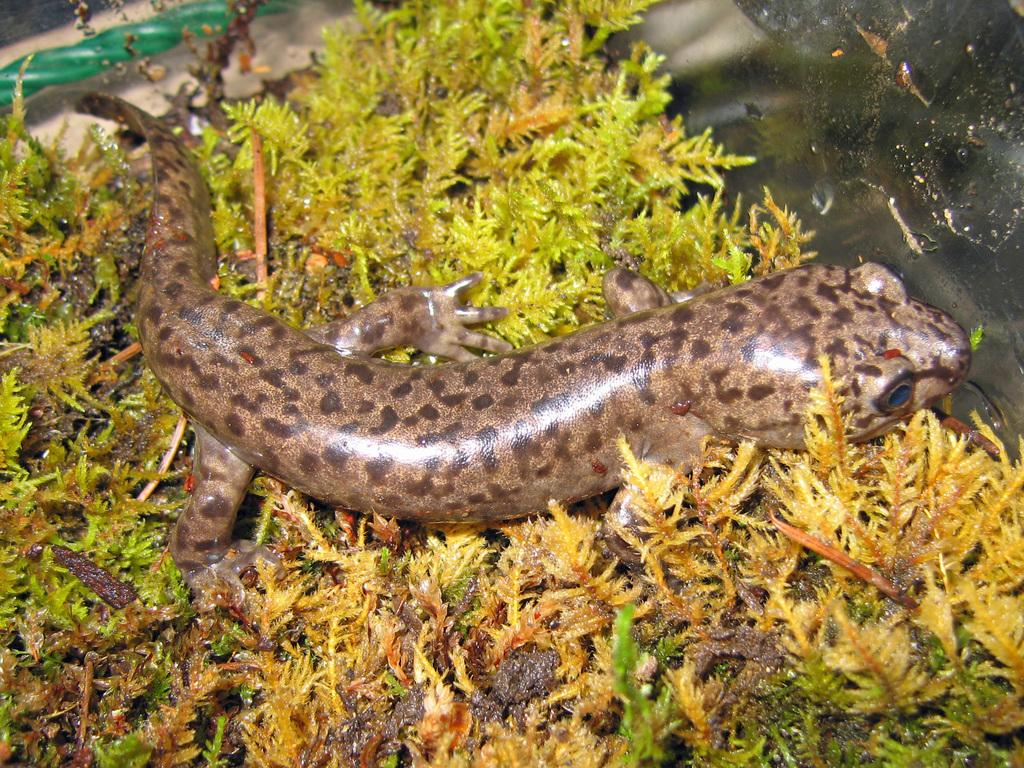What is the main subject in the center of the image? There is a reptile in the center of the image. What type of vegetation is present in the image? There are small plants in the image. What can be seen in the background of the image? There are objects visible in the background of the image. How much profit does the reptile generate in the image? There is no mention of profit or any financial aspect in the image, as it features a reptile and small plants. 